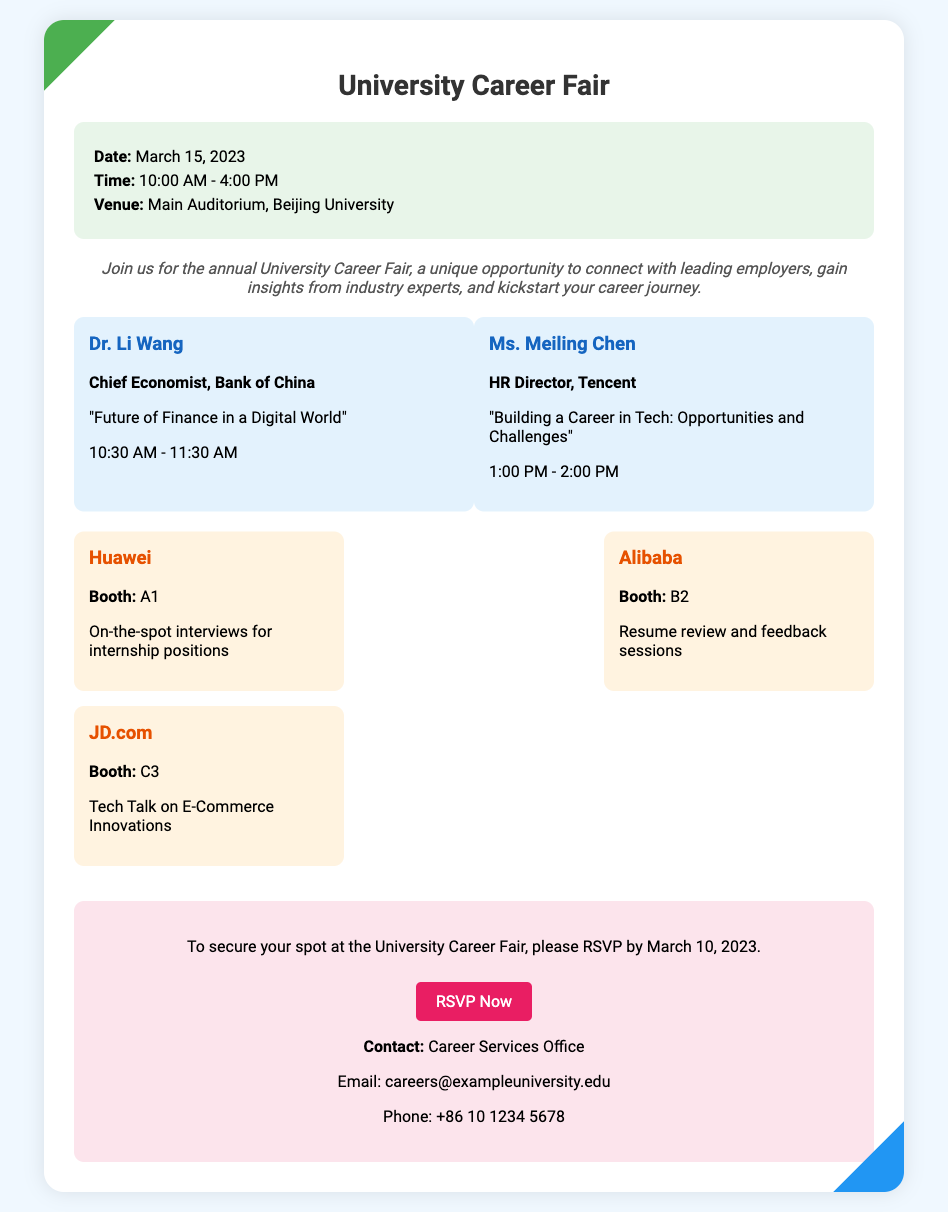What is the date of the event? The date of the University Career Fair is mentioned in the event details section of the document.
Answer: March 15, 2023 What time does the event start? The start time is specified in the event details section.
Answer: 10:00 AM Who is the Chief Economist speaking at the event? This information is provided in the speakers' section of the document.
Answer: Dr. Li Wang What is the booth number for Alibaba? The booth number for Alibaba is included in the networking section.
Answer: B2 How many keynote speakers are listed? The total number of speakers is provided in the document text.
Answer: 2 What is the deadline to RSVP for the event? The RSVP deadline is clearly specified in the RSVP section.
Answer: March 10, 2023 What is the topic of Dr. Li Wang's speech? The topic of Dr. Li Wang's speech can be found in the speakers' section.
Answer: Future of Finance in a Digital World Which company is offering on-the-spot interviews? This information is found in the networking section about company booths.
Answer: Huawei What is the contact email for the Career Services Office? The contact email is specified in the RSVP section of the document.
Answer: careers@exampleuniversity.edu 